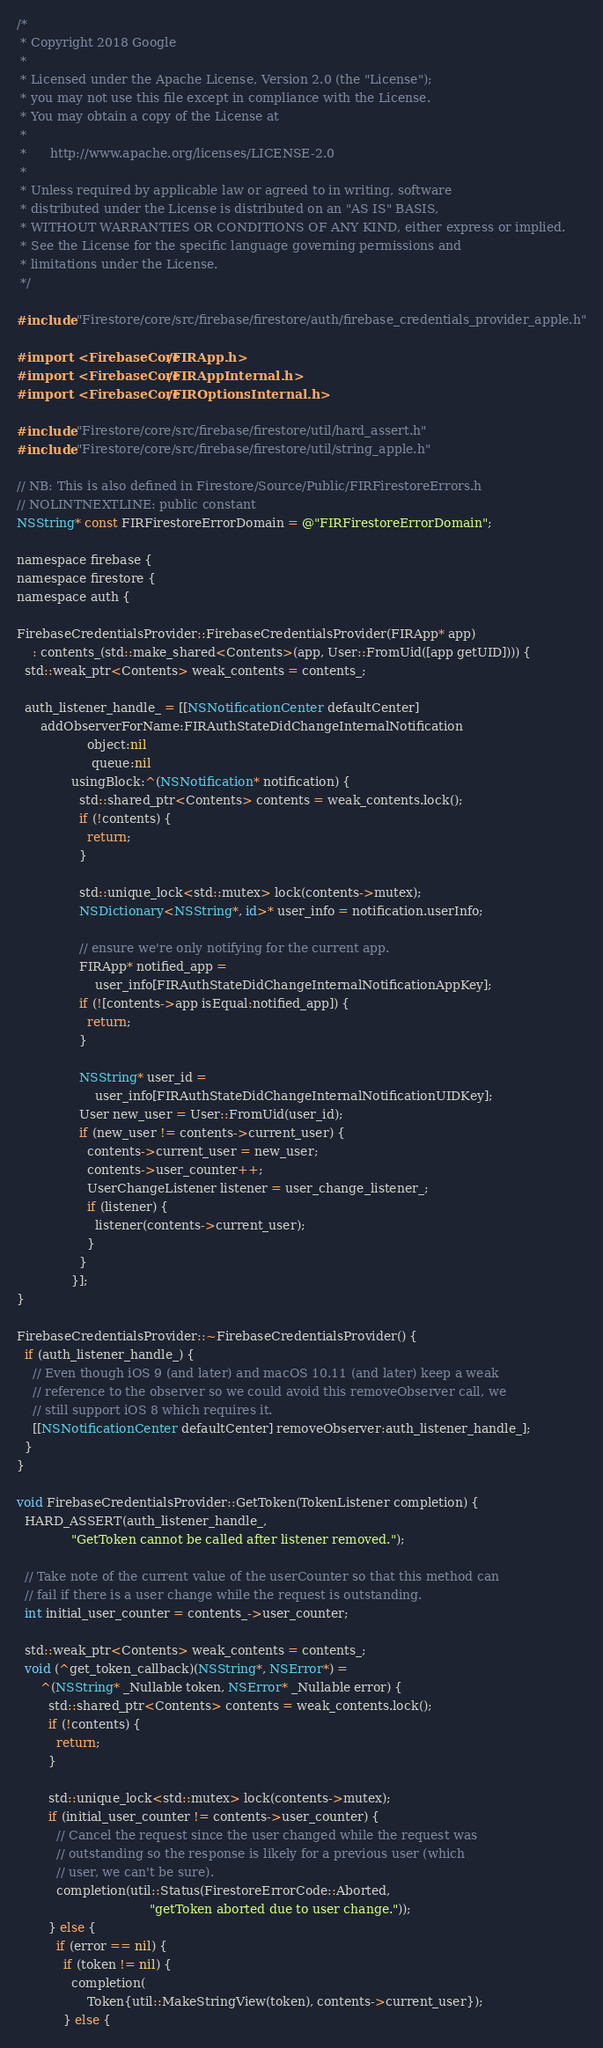<code> <loc_0><loc_0><loc_500><loc_500><_ObjectiveC_>/*
 * Copyright 2018 Google
 *
 * Licensed under the Apache License, Version 2.0 (the "License");
 * you may not use this file except in compliance with the License.
 * You may obtain a copy of the License at
 *
 *      http://www.apache.org/licenses/LICENSE-2.0
 *
 * Unless required by applicable law or agreed to in writing, software
 * distributed under the License is distributed on an "AS IS" BASIS,
 * WITHOUT WARRANTIES OR CONDITIONS OF ANY KIND, either express or implied.
 * See the License for the specific language governing permissions and
 * limitations under the License.
 */

#include "Firestore/core/src/firebase/firestore/auth/firebase_credentials_provider_apple.h"

#import <FirebaseCore/FIRApp.h>
#import <FirebaseCore/FIRAppInternal.h>
#import <FirebaseCore/FIROptionsInternal.h>

#include "Firestore/core/src/firebase/firestore/util/hard_assert.h"
#include "Firestore/core/src/firebase/firestore/util/string_apple.h"

// NB: This is also defined in Firestore/Source/Public/FIRFirestoreErrors.h
// NOLINTNEXTLINE: public constant
NSString* const FIRFirestoreErrorDomain = @"FIRFirestoreErrorDomain";

namespace firebase {
namespace firestore {
namespace auth {

FirebaseCredentialsProvider::FirebaseCredentialsProvider(FIRApp* app)
    : contents_(std::make_shared<Contents>(app, User::FromUid([app getUID]))) {
  std::weak_ptr<Contents> weak_contents = contents_;

  auth_listener_handle_ = [[NSNotificationCenter defaultCenter]
      addObserverForName:FIRAuthStateDidChangeInternalNotification
                  object:nil
                   queue:nil
              usingBlock:^(NSNotification* notification) {
                std::shared_ptr<Contents> contents = weak_contents.lock();
                if (!contents) {
                  return;
                }

                std::unique_lock<std::mutex> lock(contents->mutex);
                NSDictionary<NSString*, id>* user_info = notification.userInfo;

                // ensure we're only notifying for the current app.
                FIRApp* notified_app =
                    user_info[FIRAuthStateDidChangeInternalNotificationAppKey];
                if (![contents->app isEqual:notified_app]) {
                  return;
                }

                NSString* user_id =
                    user_info[FIRAuthStateDidChangeInternalNotificationUIDKey];
                User new_user = User::FromUid(user_id);
                if (new_user != contents->current_user) {
                  contents->current_user = new_user;
                  contents->user_counter++;
                  UserChangeListener listener = user_change_listener_;
                  if (listener) {
                    listener(contents->current_user);
                  }
                }
              }];
}

FirebaseCredentialsProvider::~FirebaseCredentialsProvider() {
  if (auth_listener_handle_) {
    // Even though iOS 9 (and later) and macOS 10.11 (and later) keep a weak
    // reference to the observer so we could avoid this removeObserver call, we
    // still support iOS 8 which requires it.
    [[NSNotificationCenter defaultCenter] removeObserver:auth_listener_handle_];
  }
}

void FirebaseCredentialsProvider::GetToken(TokenListener completion) {
  HARD_ASSERT(auth_listener_handle_,
              "GetToken cannot be called after listener removed.");

  // Take note of the current value of the userCounter so that this method can
  // fail if there is a user change while the request is outstanding.
  int initial_user_counter = contents_->user_counter;

  std::weak_ptr<Contents> weak_contents = contents_;
  void (^get_token_callback)(NSString*, NSError*) =
      ^(NSString* _Nullable token, NSError* _Nullable error) {
        std::shared_ptr<Contents> contents = weak_contents.lock();
        if (!contents) {
          return;
        }

        std::unique_lock<std::mutex> lock(contents->mutex);
        if (initial_user_counter != contents->user_counter) {
          // Cancel the request since the user changed while the request was
          // outstanding so the response is likely for a previous user (which
          // user, we can't be sure).
          completion(util::Status(FirestoreErrorCode::Aborted,
                                  "getToken aborted due to user change."));
        } else {
          if (error == nil) {
            if (token != nil) {
              completion(
                  Token{util::MakeStringView(token), contents->current_user});
            } else {</code> 